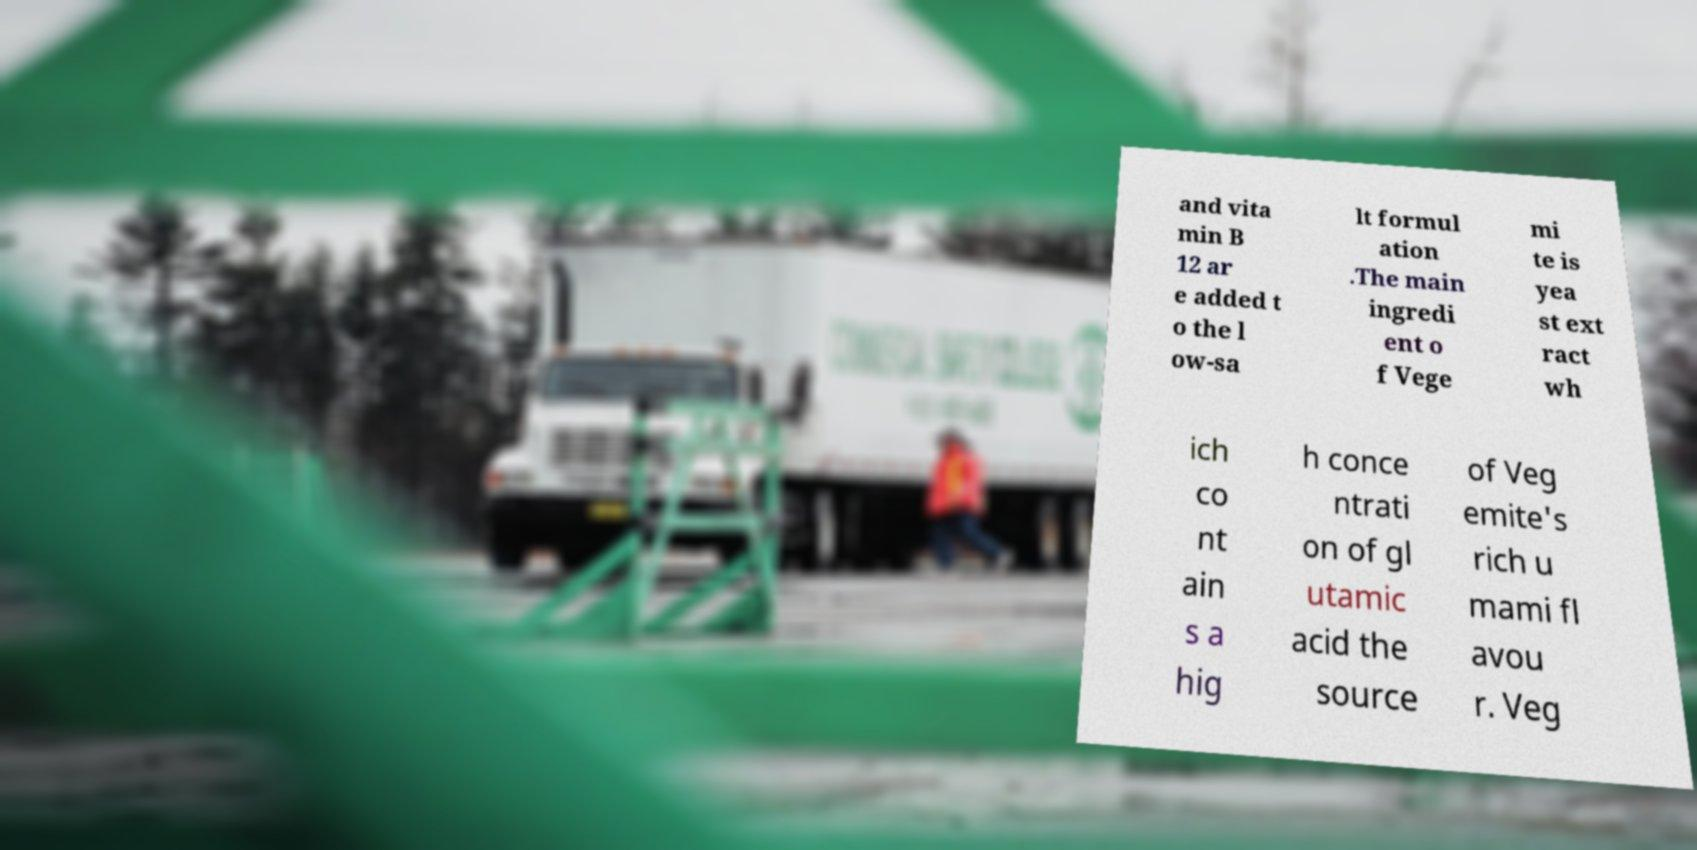Please read and relay the text visible in this image. What does it say? and vita min B 12 ar e added t o the l ow-sa lt formul ation .The main ingredi ent o f Vege mi te is yea st ext ract wh ich co nt ain s a hig h conce ntrati on of gl utamic acid the source of Veg emite's rich u mami fl avou r. Veg 